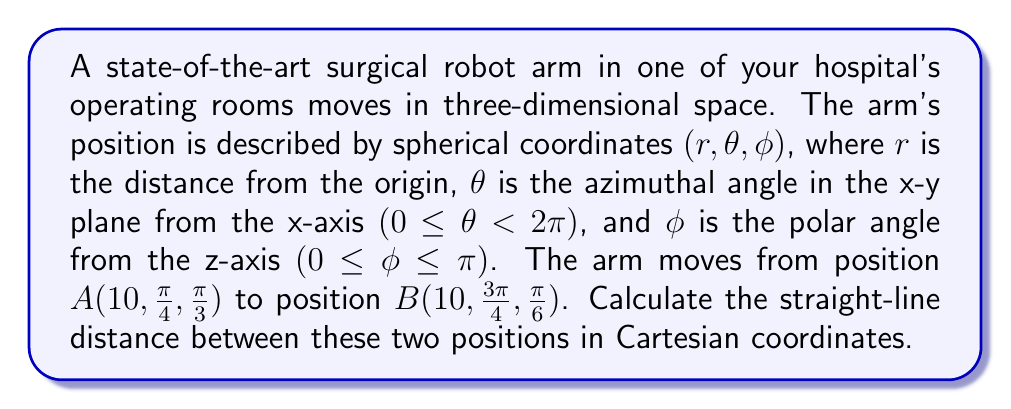Provide a solution to this math problem. To solve this problem, we need to follow these steps:

1) Convert the spherical coordinates to Cartesian coordinates for both positions.
2) Calculate the distance between the two points using the distance formula in 3D space.

Step 1: Converting spherical coordinates to Cartesian coordinates

The conversion formulas are:
$$x = r \sin\phi \cos\theta$$
$$y = r \sin\phi \sin\theta$$
$$z = r \cos\phi$$

For position A $(10, \frac{\pi}{4}, \frac{\pi}{3})$:

$$x_A = 10 \sin(\frac{\pi}{3}) \cos(\frac{\pi}{4}) = 5\sqrt{2}$$
$$y_A = 10 \sin(\frac{\pi}{3}) \sin(\frac{\pi}{4}) = 5\sqrt{2}$$
$$z_A = 10 \cos(\frac{\pi}{3}) = 5$$

For position B $(10, \frac{3\pi}{4}, \frac{\pi}{6})$:

$$x_B = 10 \sin(\frac{\pi}{6}) \cos(\frac{3\pi}{4}) = -\frac{5\sqrt{2}}{2}$$
$$y_B = 10 \sin(\frac{\pi}{6}) \sin(\frac{3\pi}{4}) = \frac{5\sqrt{2}}{2}$$
$$z_B = 10 \cos(\frac{\pi}{6}) = 5\sqrt{3}$$

Step 2: Calculating the distance

Use the 3D distance formula:
$$d = \sqrt{(x_2-x_1)^2 + (y_2-y_1)^2 + (z_2-z_1)^2}$$

Substituting our values:

$$d = \sqrt{(-\frac{5\sqrt{2}}{2}-5\sqrt{2})^2 + (\frac{5\sqrt{2}}{2}-5\sqrt{2})^2 + (5\sqrt{3}-5)^2}$$

$$d = \sqrt{(\frac{-15\sqrt{2}}{2})^2 + (\frac{-15\sqrt{2}}{2})^2 + (5\sqrt{3}-5)^2}$$

$$d = \sqrt{\frac{450}{2} + \frac{450}{2} + 25(3-2\sqrt{3}+1)}$$

$$d = \sqrt{450 + 100 - 50\sqrt{3}}$$

$$d = 10\sqrt{55 - 5\sqrt{3}}$$
Answer: $10\sqrt{55 - 5\sqrt{3}}$ 